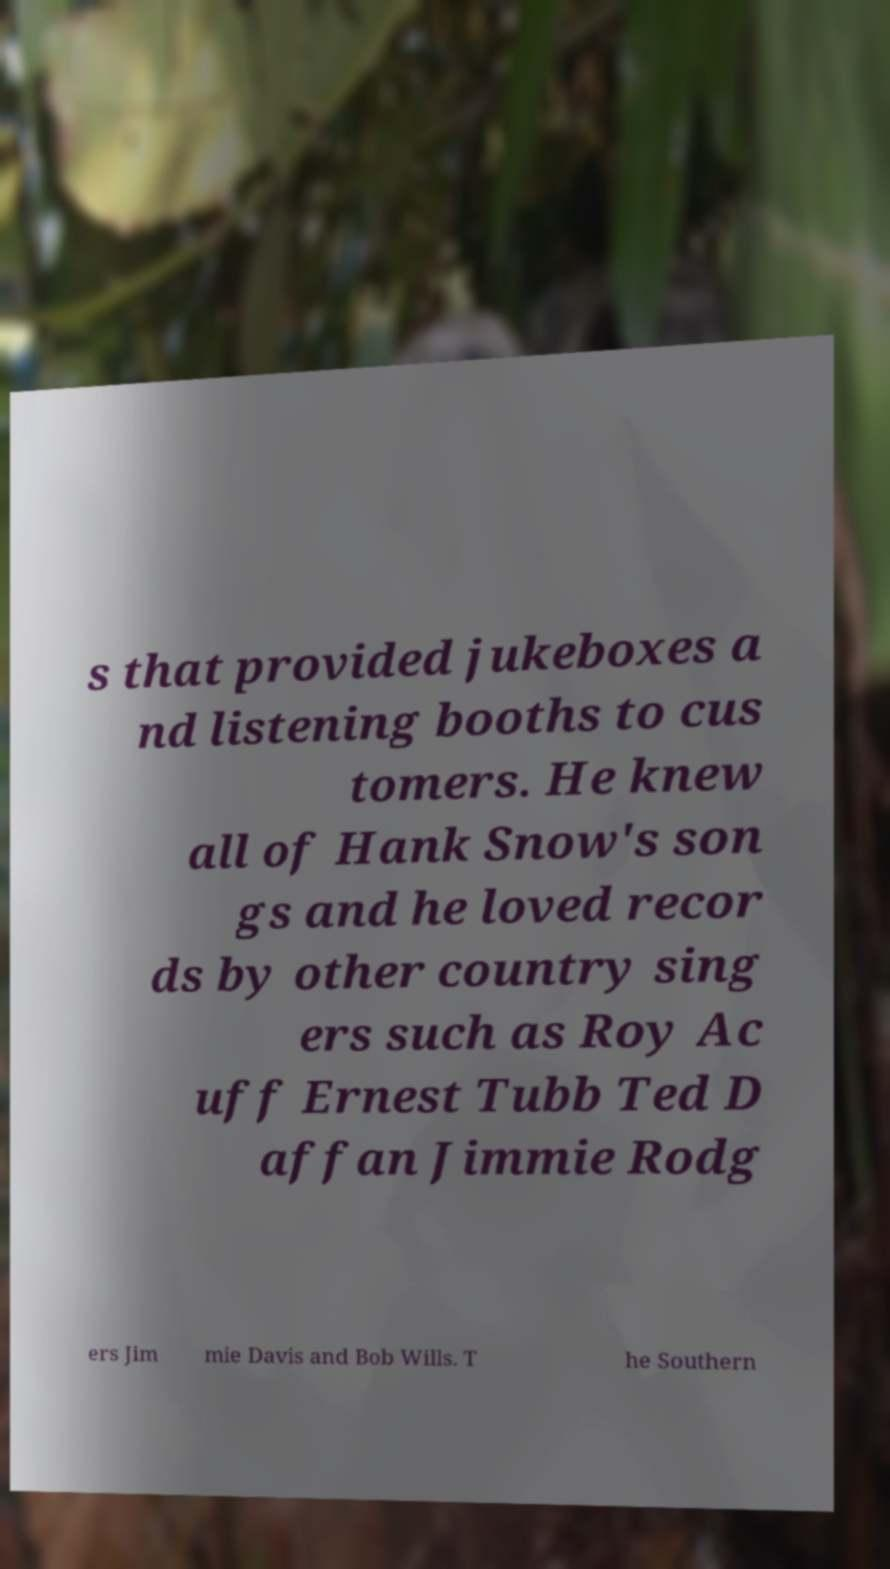What messages or text are displayed in this image? I need them in a readable, typed format. s that provided jukeboxes a nd listening booths to cus tomers. He knew all of Hank Snow's son gs and he loved recor ds by other country sing ers such as Roy Ac uff Ernest Tubb Ted D affan Jimmie Rodg ers Jim mie Davis and Bob Wills. T he Southern 